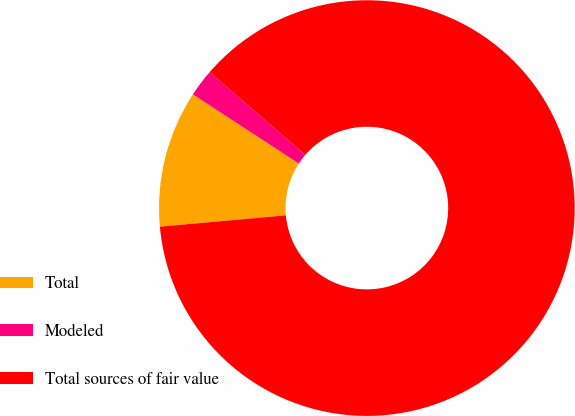<chart> <loc_0><loc_0><loc_500><loc_500><pie_chart><fcel>Total<fcel>Modeled<fcel>Total sources of fair value<nl><fcel>10.64%<fcel>2.13%<fcel>87.23%<nl></chart> 